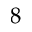Convert formula to latex. <formula><loc_0><loc_0><loc_500><loc_500>8</formula> 